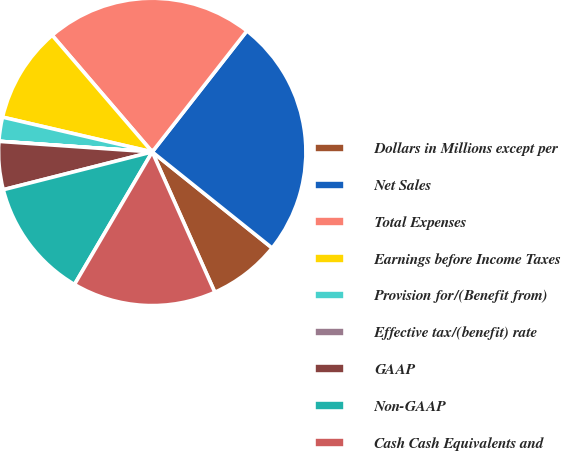<chart> <loc_0><loc_0><loc_500><loc_500><pie_chart><fcel>Dollars in Millions except per<fcel>Net Sales<fcel>Total Expenses<fcel>Earnings before Income Taxes<fcel>Provision for/(Benefit from)<fcel>Effective tax/(benefit) rate<fcel>GAAP<fcel>Non-GAAP<fcel>Cash Cash Equivalents and<nl><fcel>7.57%<fcel>25.19%<fcel>21.85%<fcel>10.08%<fcel>2.53%<fcel>0.01%<fcel>5.05%<fcel>12.6%<fcel>15.12%<nl></chart> 